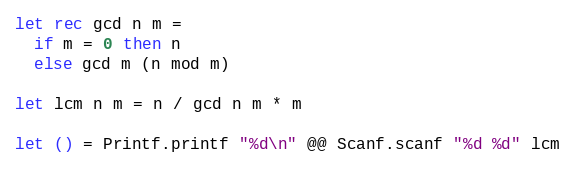<code> <loc_0><loc_0><loc_500><loc_500><_OCaml_>let rec gcd n m =
  if m = 0 then n
  else gcd m (n mod m)

let lcm n m = n / gcd n m * m

let () = Printf.printf "%d\n" @@ Scanf.scanf "%d %d" lcm
</code> 